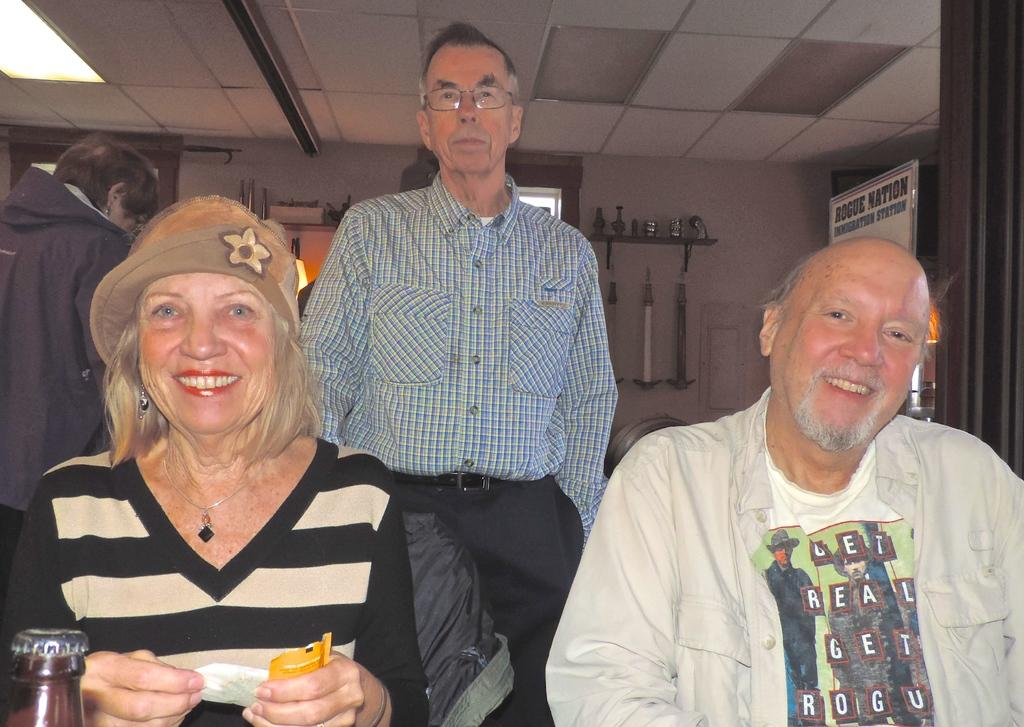<image>
Present a compact description of the photo's key features. three older people, one wearing a shirt that has on it get real get rogu 